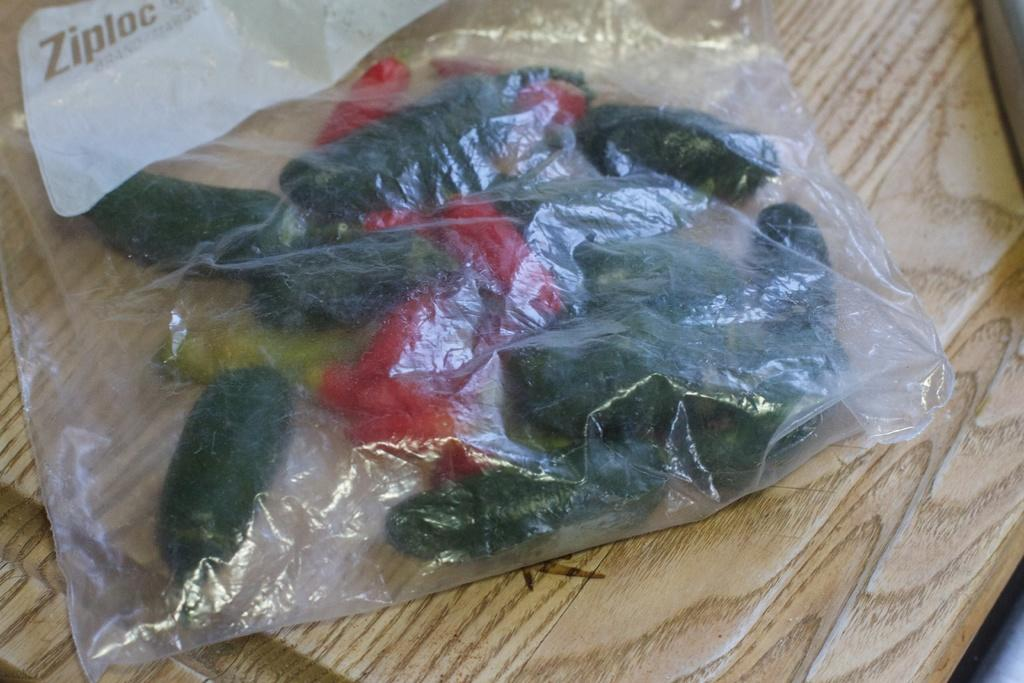What is the main object in the image? There is a cover in the image. What is depicted on the cover? The cover has vegetables on it. What type of surface is visible in the image? The wooden surface is present in the image. How many cacti can be seen on the wooden surface in the image? There are no cacti present in the image; the cover has vegetables on it. 